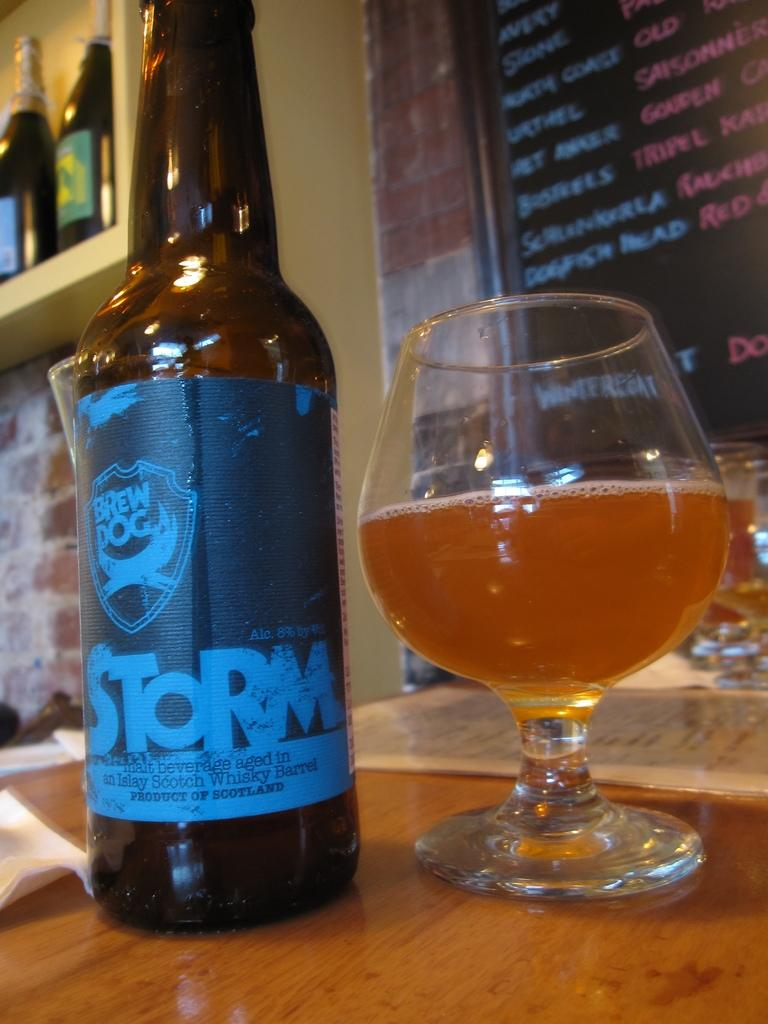<image>
Summarize the visual content of the image. A half glass full of beer next to a bottle of beer from Brew Dog that says STORM 